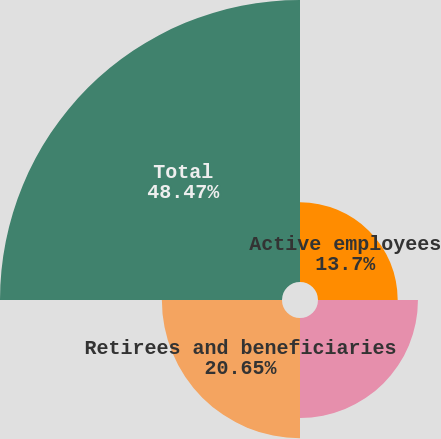<chart> <loc_0><loc_0><loc_500><loc_500><pie_chart><fcel>Active employees<fcel>Vested former employees<fcel>Retirees and beneficiaries<fcel>Total<nl><fcel>13.7%<fcel>17.18%<fcel>20.65%<fcel>48.47%<nl></chart> 